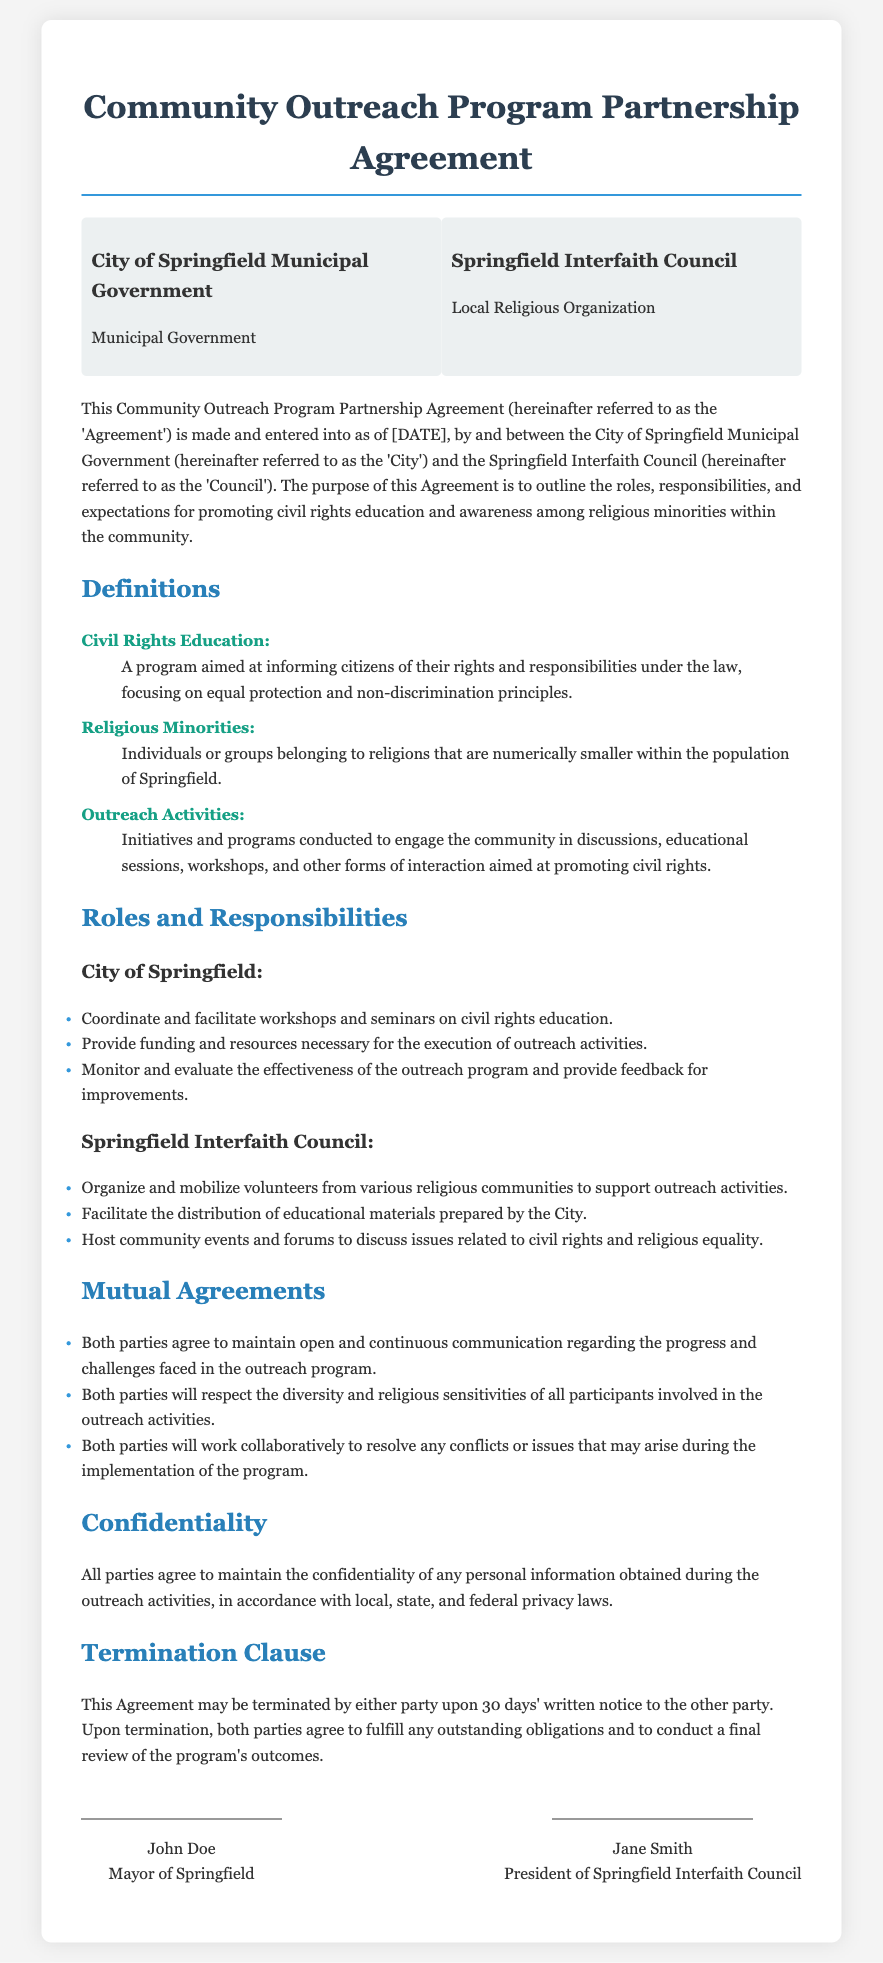What is the title of the document? The title of the document is specified at the beginning, indicating the subject matter of the agreement.
Answer: Community Outreach Program Partnership Agreement Who are the parties involved in the contract? The parties are defined in the section where the parties are introduced, detailing their names and roles.
Answer: City of Springfield Municipal Government and Springfield Interfaith Council What is the purpose of this Agreement? The purpose is stated clearly in the introductory paragraph, summarizing the primary aim of the partnership.
Answer: To outline the roles, responsibilities, and expectations for promoting civil rights education and awareness What does "Civil Rights Education" entail? The term is defined under the Definitions section, providing clarity on its meaning within the context of the agreement.
Answer: A program aimed at informing citizens of their rights and responsibilities under the law How long is the notice period for termination of the Agreement? The termination clause specifies the duration required for either party to terminate the contract.
Answer: 30 days What are the roles of the City of Springfield? The document specifies multiple responsibilities assigned to the City, emphasizing its contributions to the partnership.
Answer: Coordinate and facilitate workshops and seminars on civil rights education What is one of the responsibilities of the Springfield Interfaith Council? The document enumerates the responsibilities of the Council, highlighting its role in promoting outreach activities.
Answer: Organize and mobilize volunteers from various religious communities What should both parties maintain during the outreach program? The mutual agreements section outlines the expectations regarding collaboration and communication between the parties.
Answer: Open and continuous communication What must all parties agree to maintain concerning personal information? The confidentiality section emphasizes the importance of privacy in the outreach activities as stated in the document.
Answer: Confidentiality of any personal information 